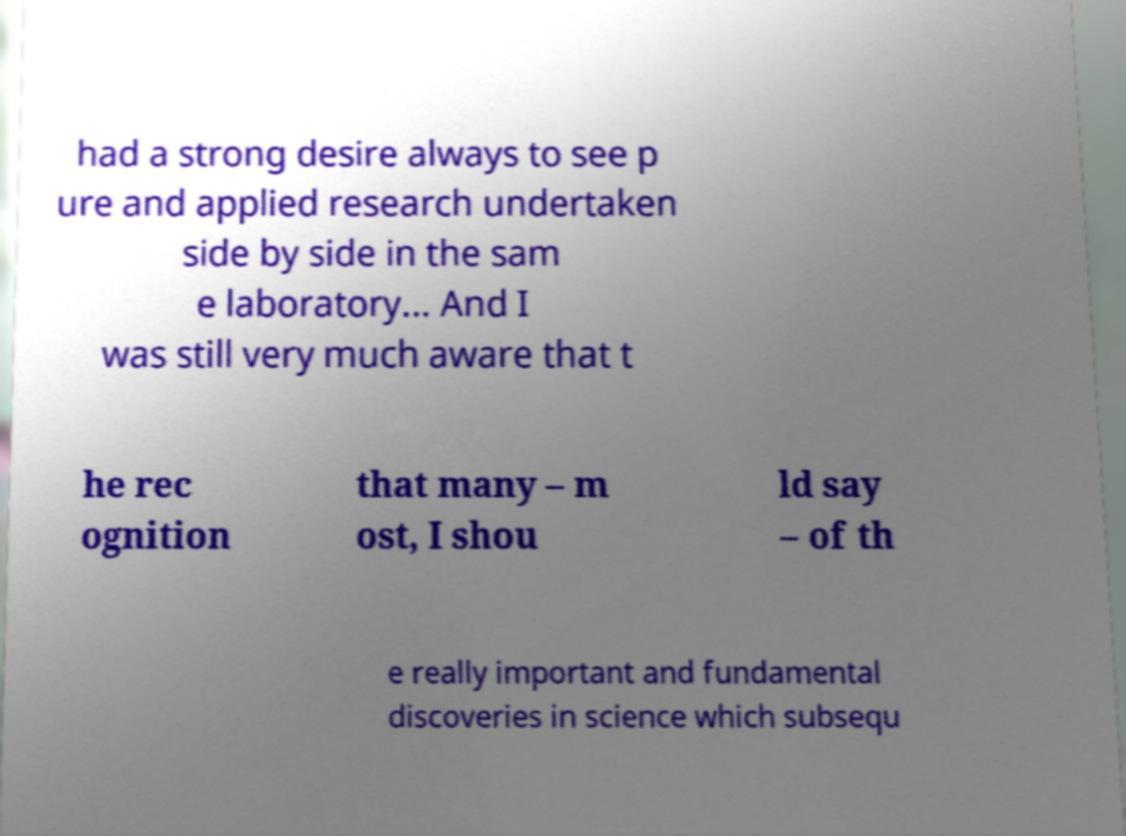Please read and relay the text visible in this image. What does it say? had a strong desire always to see p ure and applied research undertaken side by side in the sam e laboratory... And I was still very much aware that t he rec ognition that many – m ost, I shou ld say – of th e really important and fundamental discoveries in science which subsequ 